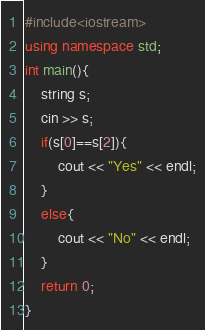Convert code to text. <code><loc_0><loc_0><loc_500><loc_500><_C++_>#include<iostream>
using namespace std;
int main(){
	string s;
  	cin >> s;
  	if(s[0]==s[2]){
    	cout << "Yes" << endl;
    }
  	else{
    	cout << "No" << endl;
    }
	return 0;
}</code> 